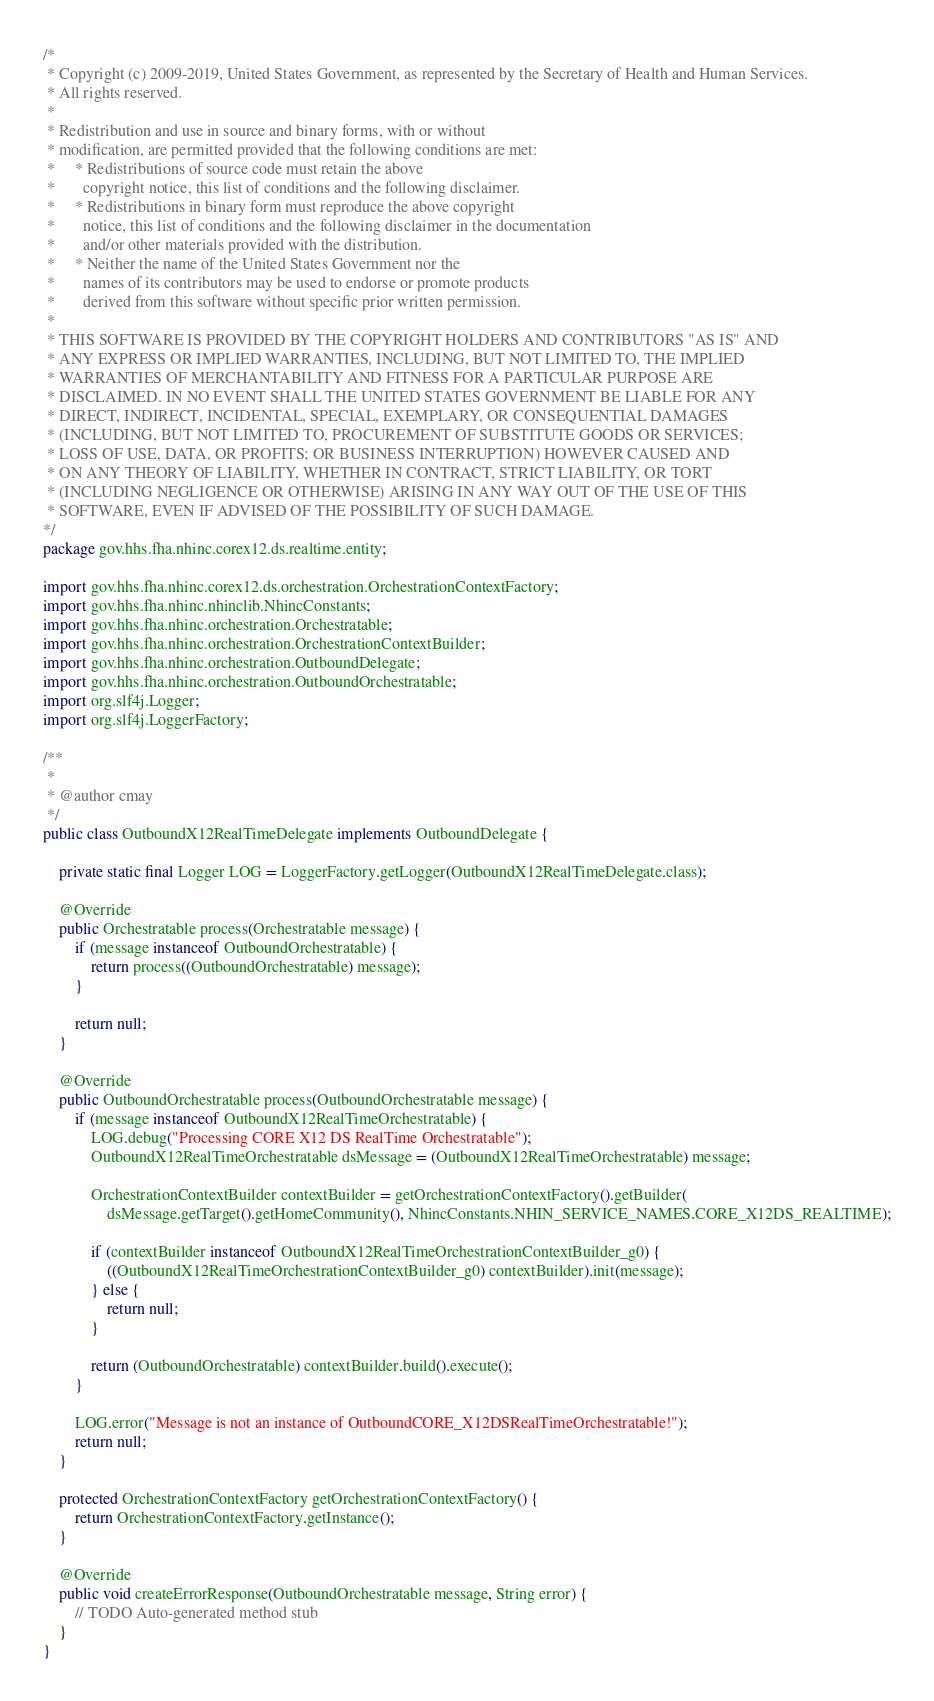<code> <loc_0><loc_0><loc_500><loc_500><_Java_>/*
 * Copyright (c) 2009-2019, United States Government, as represented by the Secretary of Health and Human Services.
 * All rights reserved.
 *  
 * Redistribution and use in source and binary forms, with or without
 * modification, are permitted provided that the following conditions are met:
 *     * Redistributions of source code must retain the above
 *       copyright notice, this list of conditions and the following disclaimer.
 *     * Redistributions in binary form must reproduce the above copyright
 *       notice, this list of conditions and the following disclaimer in the documentation
 *       and/or other materials provided with the distribution.
 *     * Neither the name of the United States Government nor the
 *       names of its contributors may be used to endorse or promote products
 *       derived from this software without specific prior written permission.
 * 
 * THIS SOFTWARE IS PROVIDED BY THE COPYRIGHT HOLDERS AND CONTRIBUTORS "AS IS" AND
 * ANY EXPRESS OR IMPLIED WARRANTIES, INCLUDING, BUT NOT LIMITED TO, THE IMPLIED
 * WARRANTIES OF MERCHANTABILITY AND FITNESS FOR A PARTICULAR PURPOSE ARE
 * DISCLAIMED. IN NO EVENT SHALL THE UNITED STATES GOVERNMENT BE LIABLE FOR ANY
 * DIRECT, INDIRECT, INCIDENTAL, SPECIAL, EXEMPLARY, OR CONSEQUENTIAL DAMAGES
 * (INCLUDING, BUT NOT LIMITED TO, PROCUREMENT OF SUBSTITUTE GOODS OR SERVICES;
 * LOSS OF USE, DATA, OR PROFITS; OR BUSINESS INTERRUPTION) HOWEVER CAUSED AND
 * ON ANY THEORY OF LIABILITY, WHETHER IN CONTRACT, STRICT LIABILITY, OR TORT
 * (INCLUDING NEGLIGENCE OR OTHERWISE) ARISING IN ANY WAY OUT OF THE USE OF THIS
 * SOFTWARE, EVEN IF ADVISED OF THE POSSIBILITY OF SUCH DAMAGE.
*/
package gov.hhs.fha.nhinc.corex12.ds.realtime.entity;

import gov.hhs.fha.nhinc.corex12.ds.orchestration.OrchestrationContextFactory;
import gov.hhs.fha.nhinc.nhinclib.NhincConstants;
import gov.hhs.fha.nhinc.orchestration.Orchestratable;
import gov.hhs.fha.nhinc.orchestration.OrchestrationContextBuilder;
import gov.hhs.fha.nhinc.orchestration.OutboundDelegate;
import gov.hhs.fha.nhinc.orchestration.OutboundOrchestratable;
import org.slf4j.Logger;
import org.slf4j.LoggerFactory;

/**
 *
 * @author cmay
 */
public class OutboundX12RealTimeDelegate implements OutboundDelegate {

    private static final Logger LOG = LoggerFactory.getLogger(OutboundX12RealTimeDelegate.class);

    @Override
    public Orchestratable process(Orchestratable message) {
        if (message instanceof OutboundOrchestratable) {
            return process((OutboundOrchestratable) message);
        }

        return null;
    }

    @Override
    public OutboundOrchestratable process(OutboundOrchestratable message) {
        if (message instanceof OutboundX12RealTimeOrchestratable) {
            LOG.debug("Processing CORE X12 DS RealTime Orchestratable");
            OutboundX12RealTimeOrchestratable dsMessage = (OutboundX12RealTimeOrchestratable) message;

            OrchestrationContextBuilder contextBuilder = getOrchestrationContextFactory().getBuilder(
                dsMessage.getTarget().getHomeCommunity(), NhincConstants.NHIN_SERVICE_NAMES.CORE_X12DS_REALTIME);

            if (contextBuilder instanceof OutboundX12RealTimeOrchestrationContextBuilder_g0) {
                ((OutboundX12RealTimeOrchestrationContextBuilder_g0) contextBuilder).init(message);
            } else {
                return null;
            }

            return (OutboundOrchestratable) contextBuilder.build().execute();
        }

        LOG.error("Message is not an instance of OutboundCORE_X12DSRealTimeOrchestratable!");
        return null;
    }

    protected OrchestrationContextFactory getOrchestrationContextFactory() {
        return OrchestrationContextFactory.getInstance();
    }

    @Override
    public void createErrorResponse(OutboundOrchestratable message, String error) {
        // TODO Auto-generated method stub
    }
}
</code> 